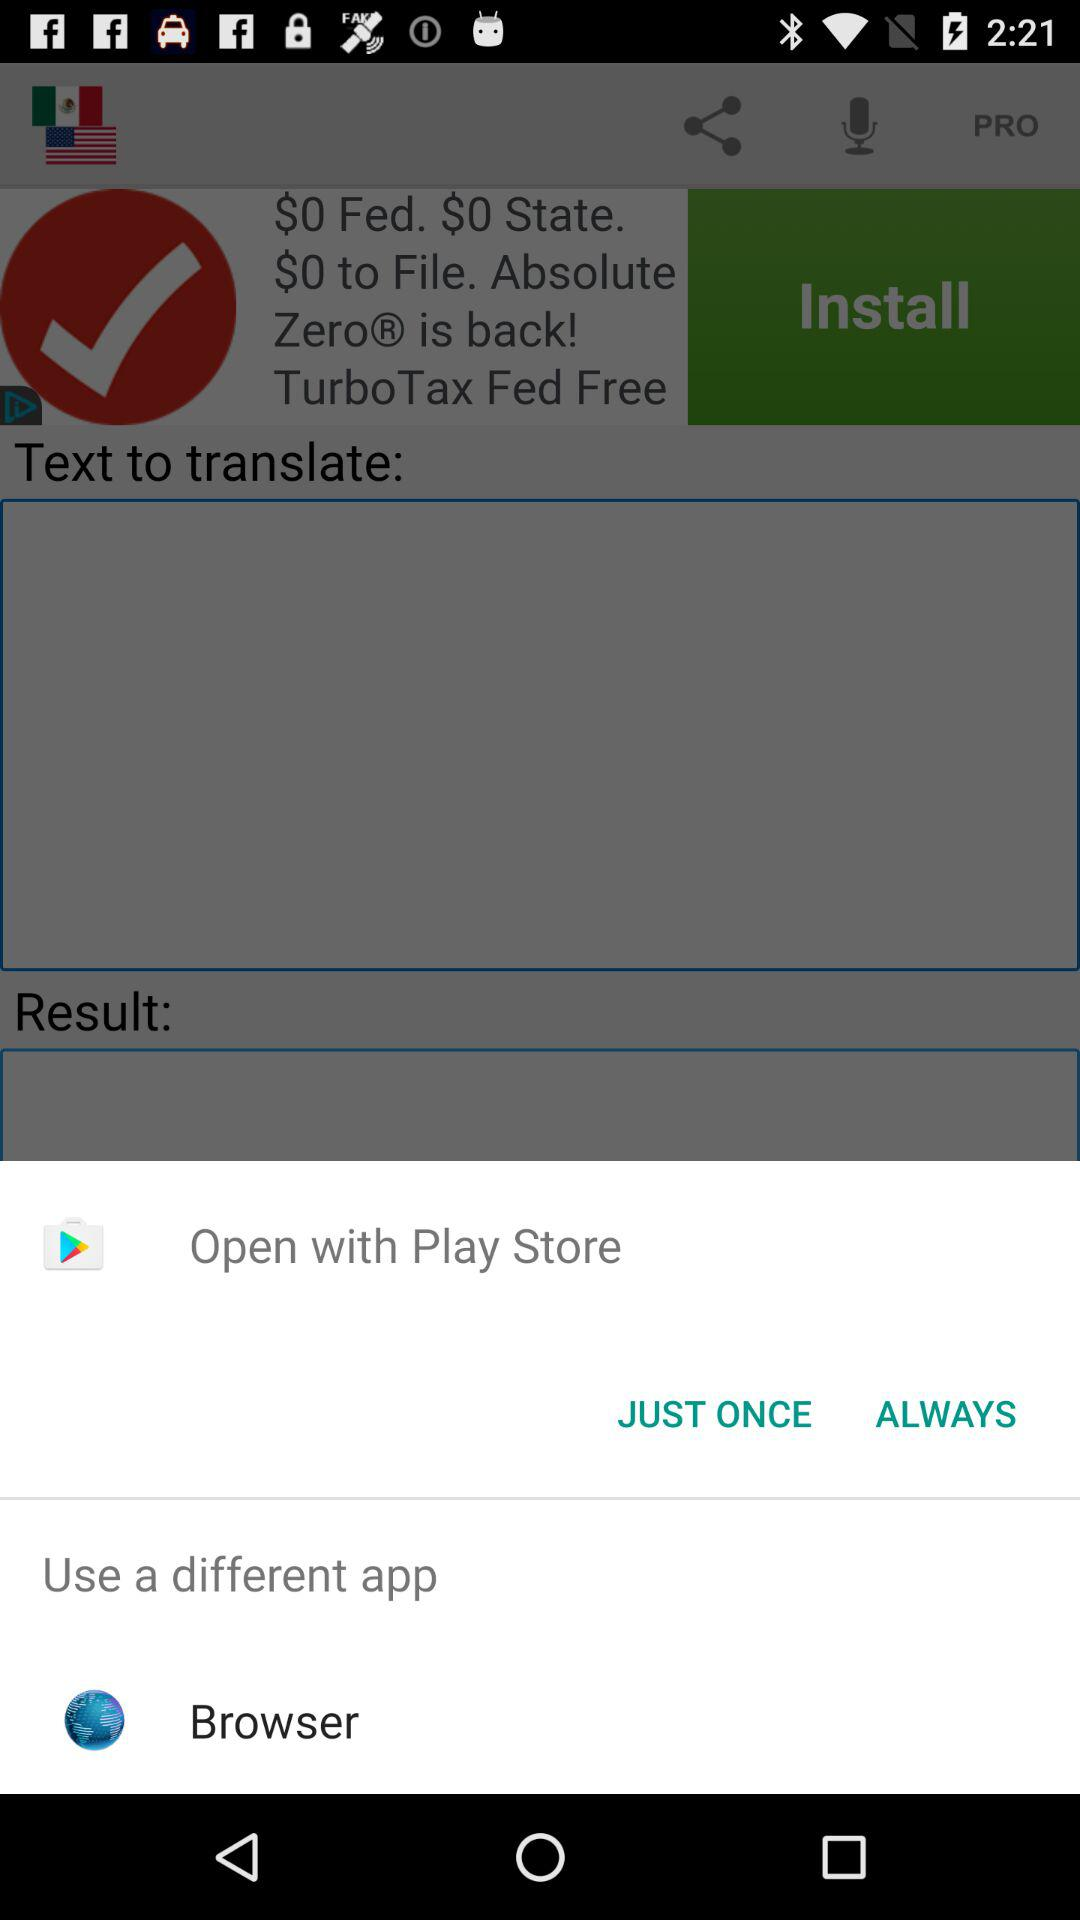How many words are entered to be translated?
When the provided information is insufficient, respond with <no answer>. <no answer> 